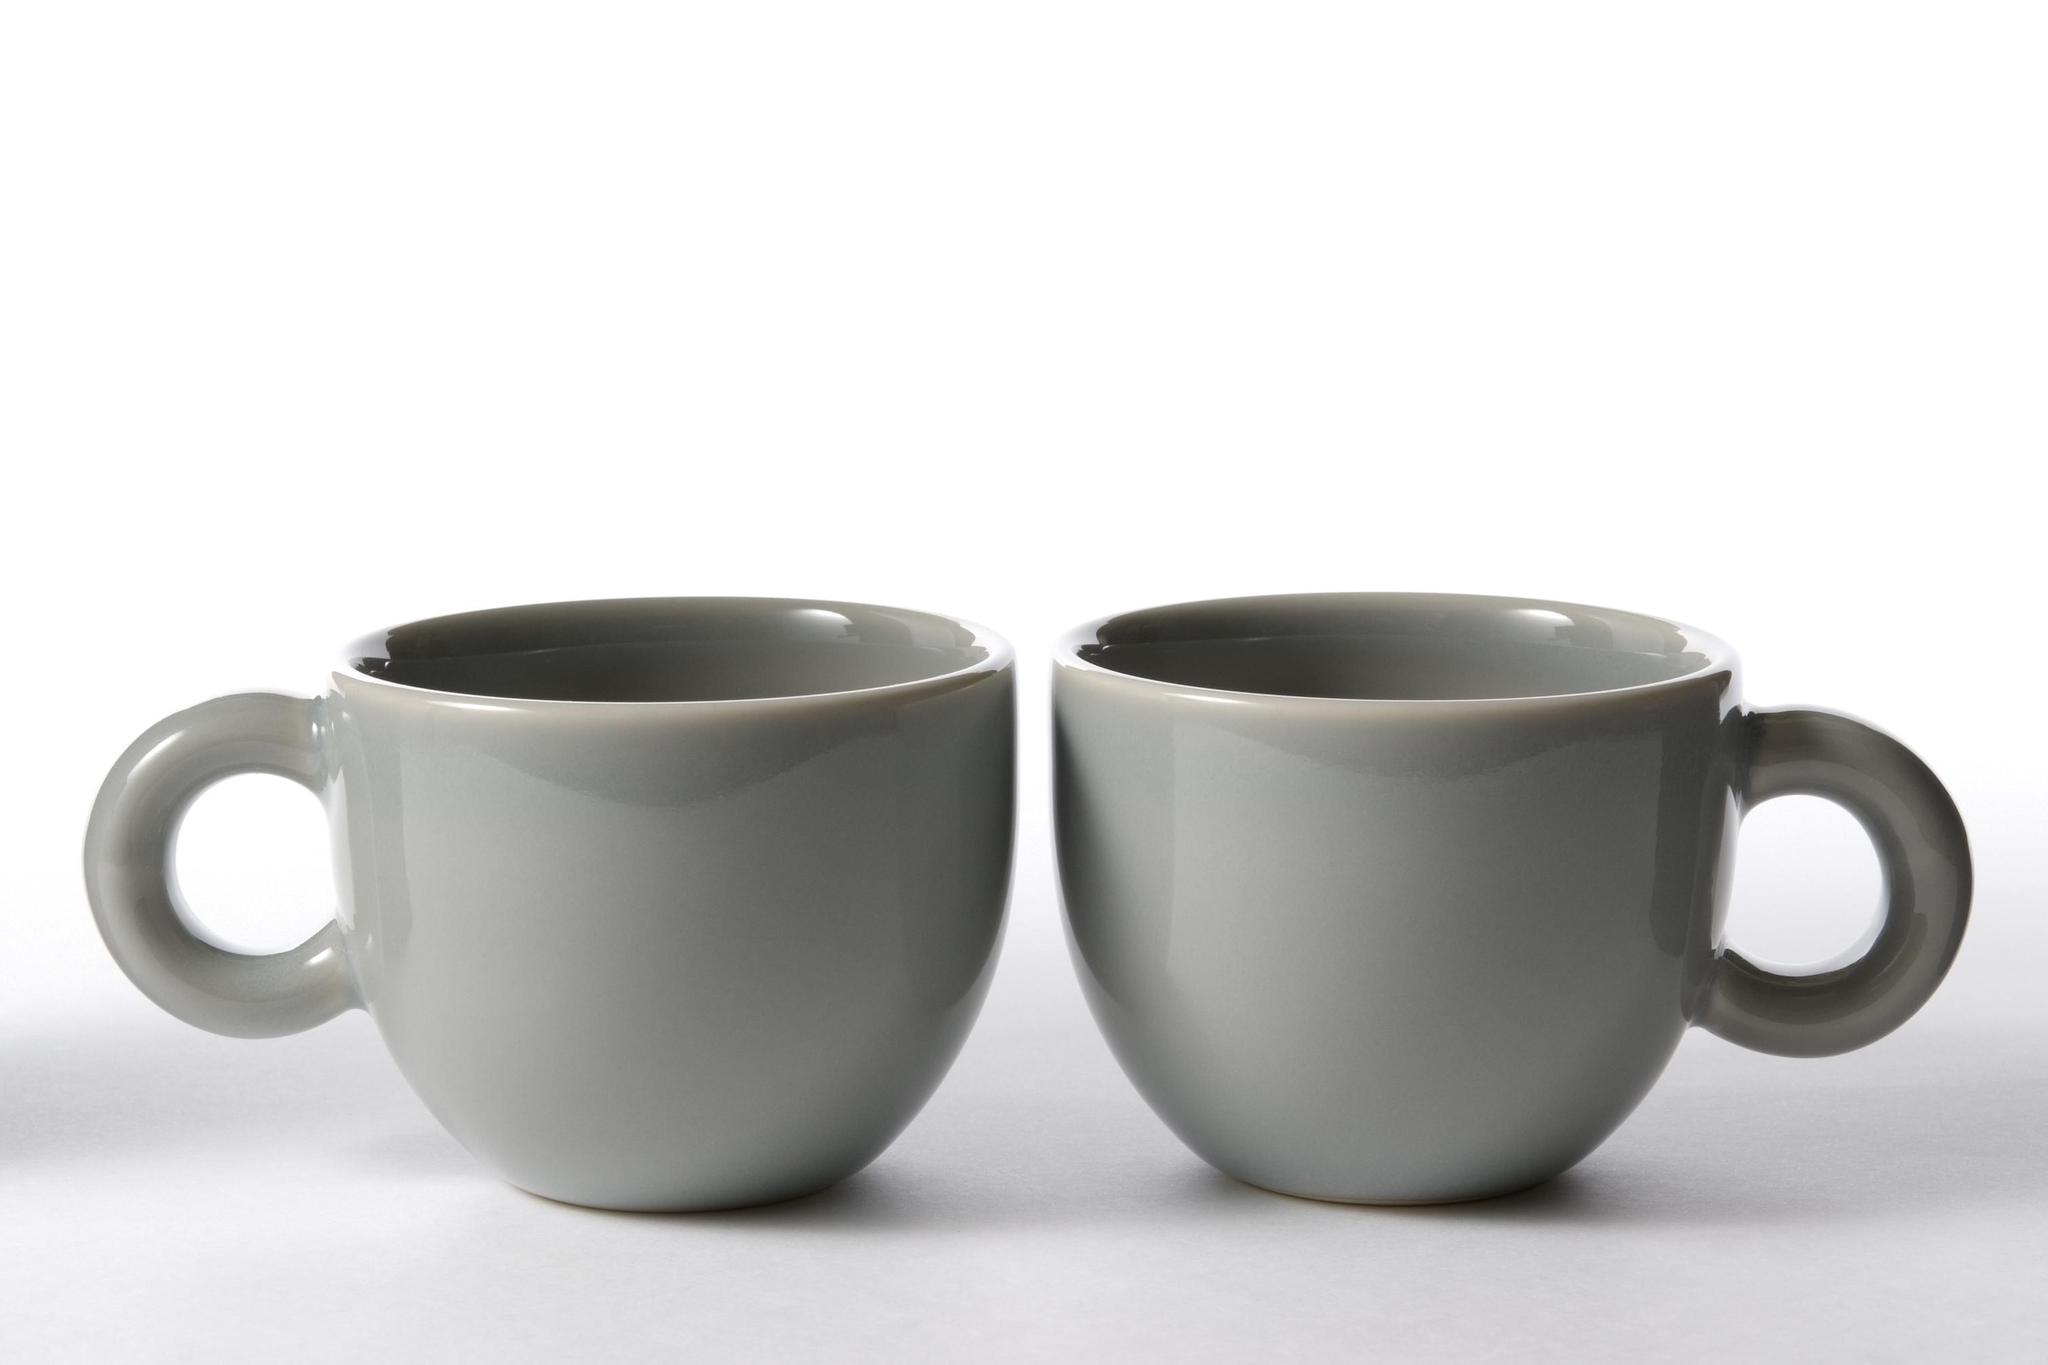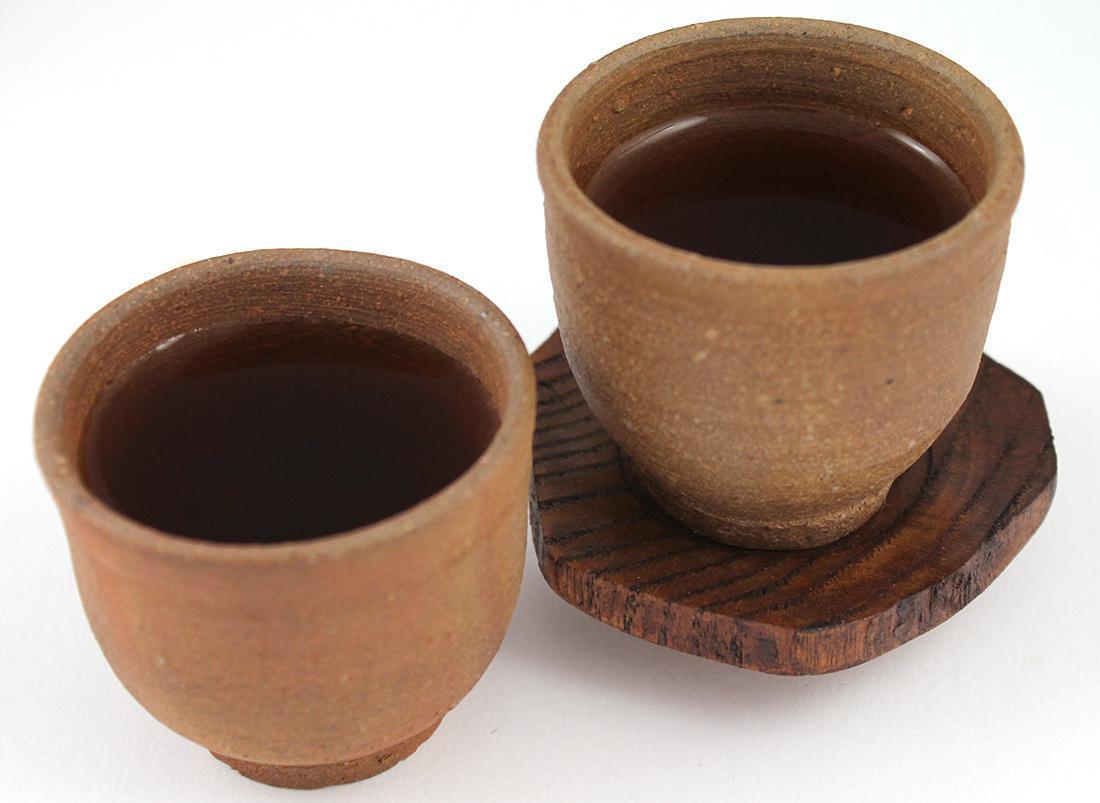The first image is the image on the left, the second image is the image on the right. Assess this claim about the two images: "There is a teapot with cups". Correct or not? Answer yes or no. No. The first image is the image on the left, the second image is the image on the right. Analyze the images presented: Is the assertion "An image of a pair of filled mugs includes a small pile of loose coffee beans." valid? Answer yes or no. No. 